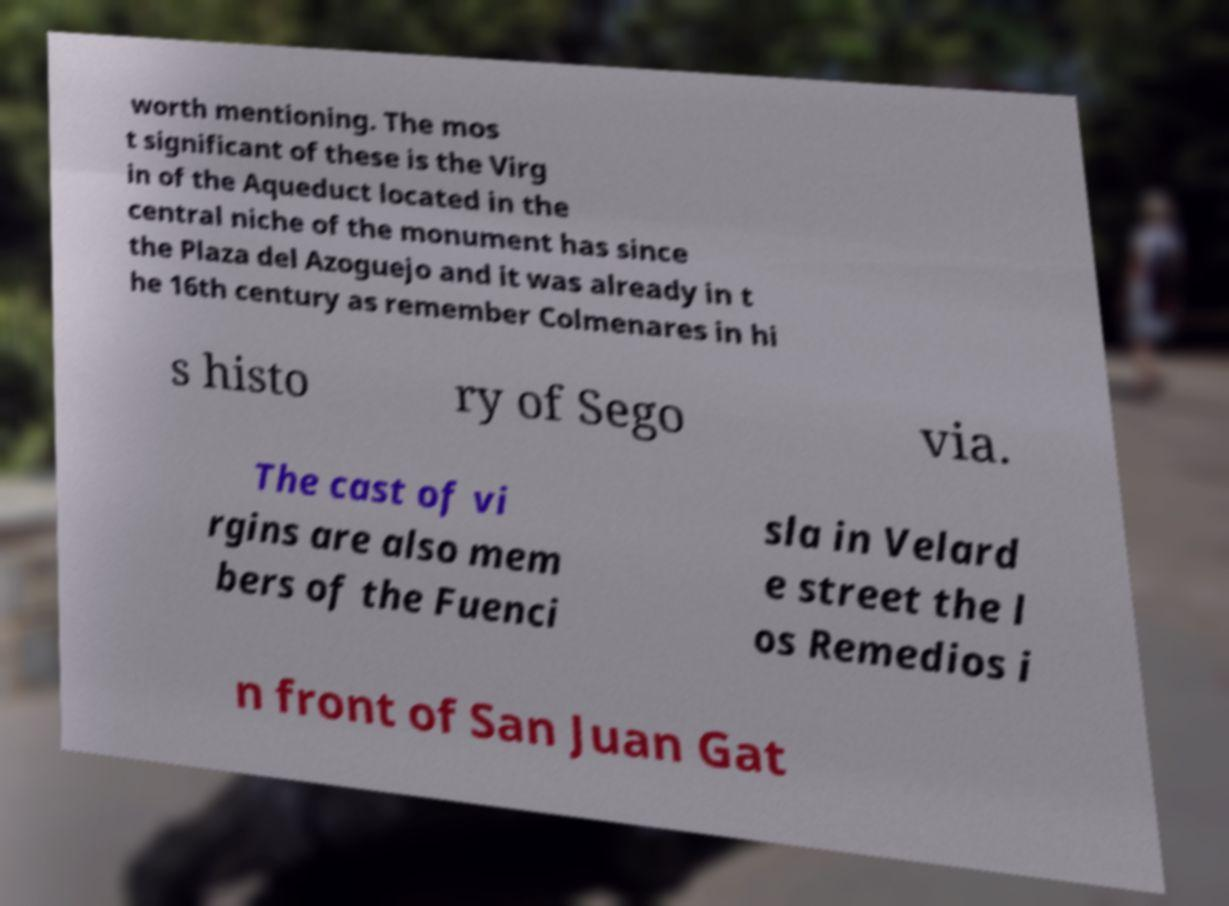I need the written content from this picture converted into text. Can you do that? worth mentioning. The mos t significant of these is the Virg in of the Aqueduct located in the central niche of the monument has since the Plaza del Azoguejo and it was already in t he 16th century as remember Colmenares in hi s histo ry of Sego via. The cast of vi rgins are also mem bers of the Fuenci sla in Velard e street the l os Remedios i n front of San Juan Gat 